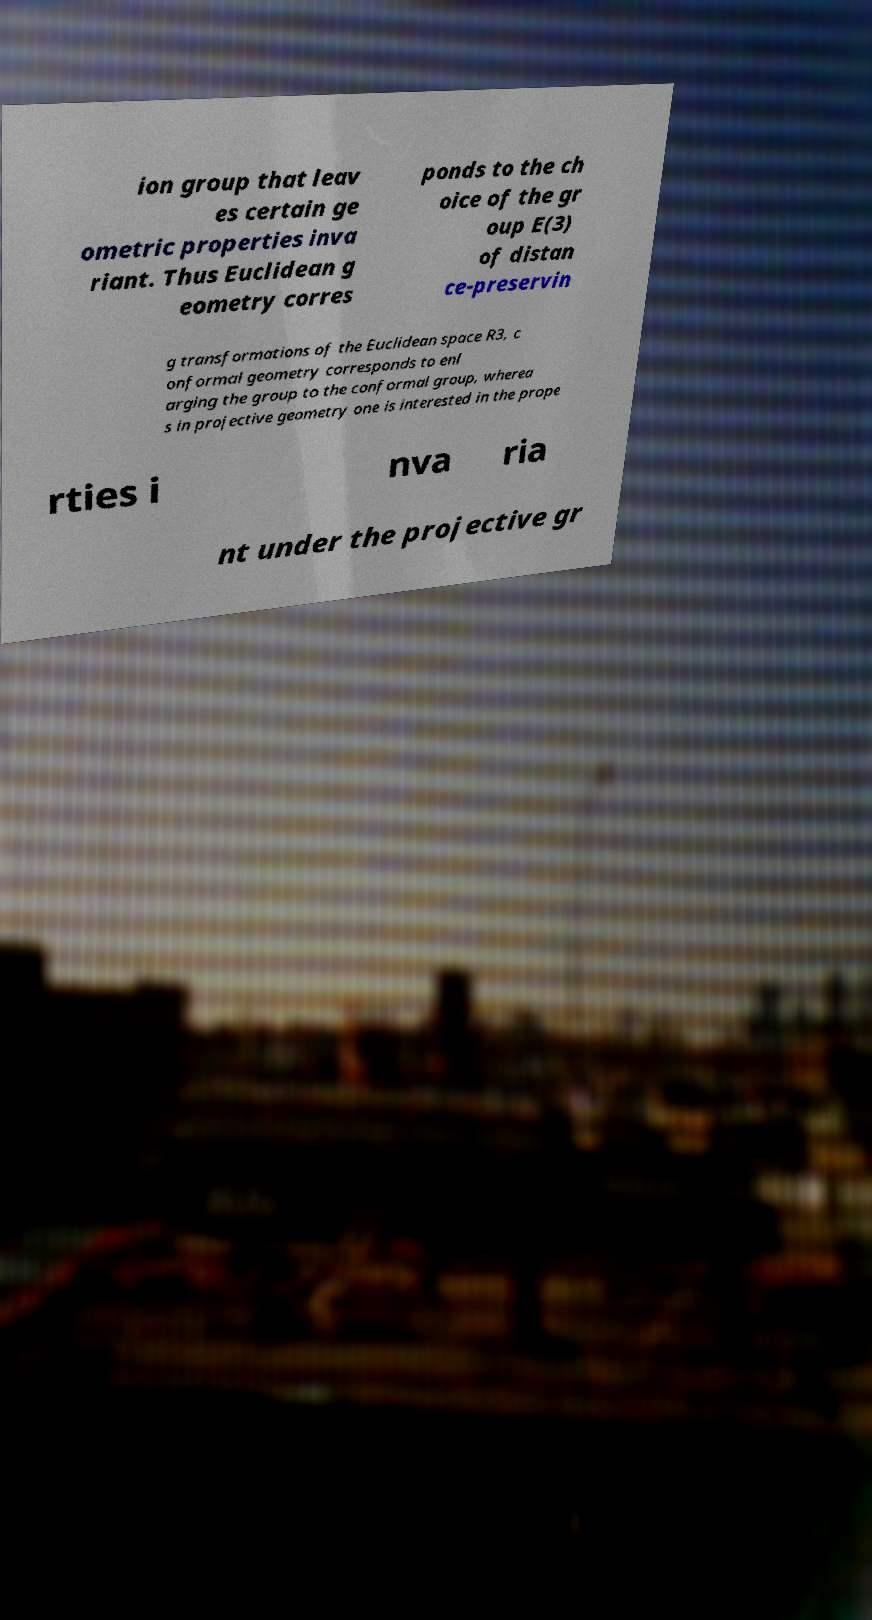Can you accurately transcribe the text from the provided image for me? ion group that leav es certain ge ometric properties inva riant. Thus Euclidean g eometry corres ponds to the ch oice of the gr oup E(3) of distan ce-preservin g transformations of the Euclidean space R3, c onformal geometry corresponds to enl arging the group to the conformal group, wherea s in projective geometry one is interested in the prope rties i nva ria nt under the projective gr 